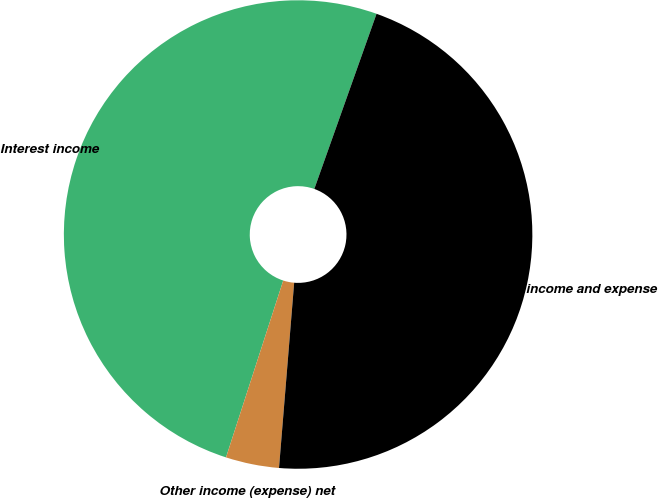Convert chart to OTSL. <chart><loc_0><loc_0><loc_500><loc_500><pie_chart><fcel>Interest income<fcel>Other income (expense) net<fcel>Total other income and expense<nl><fcel>50.46%<fcel>3.68%<fcel>45.87%<nl></chart> 